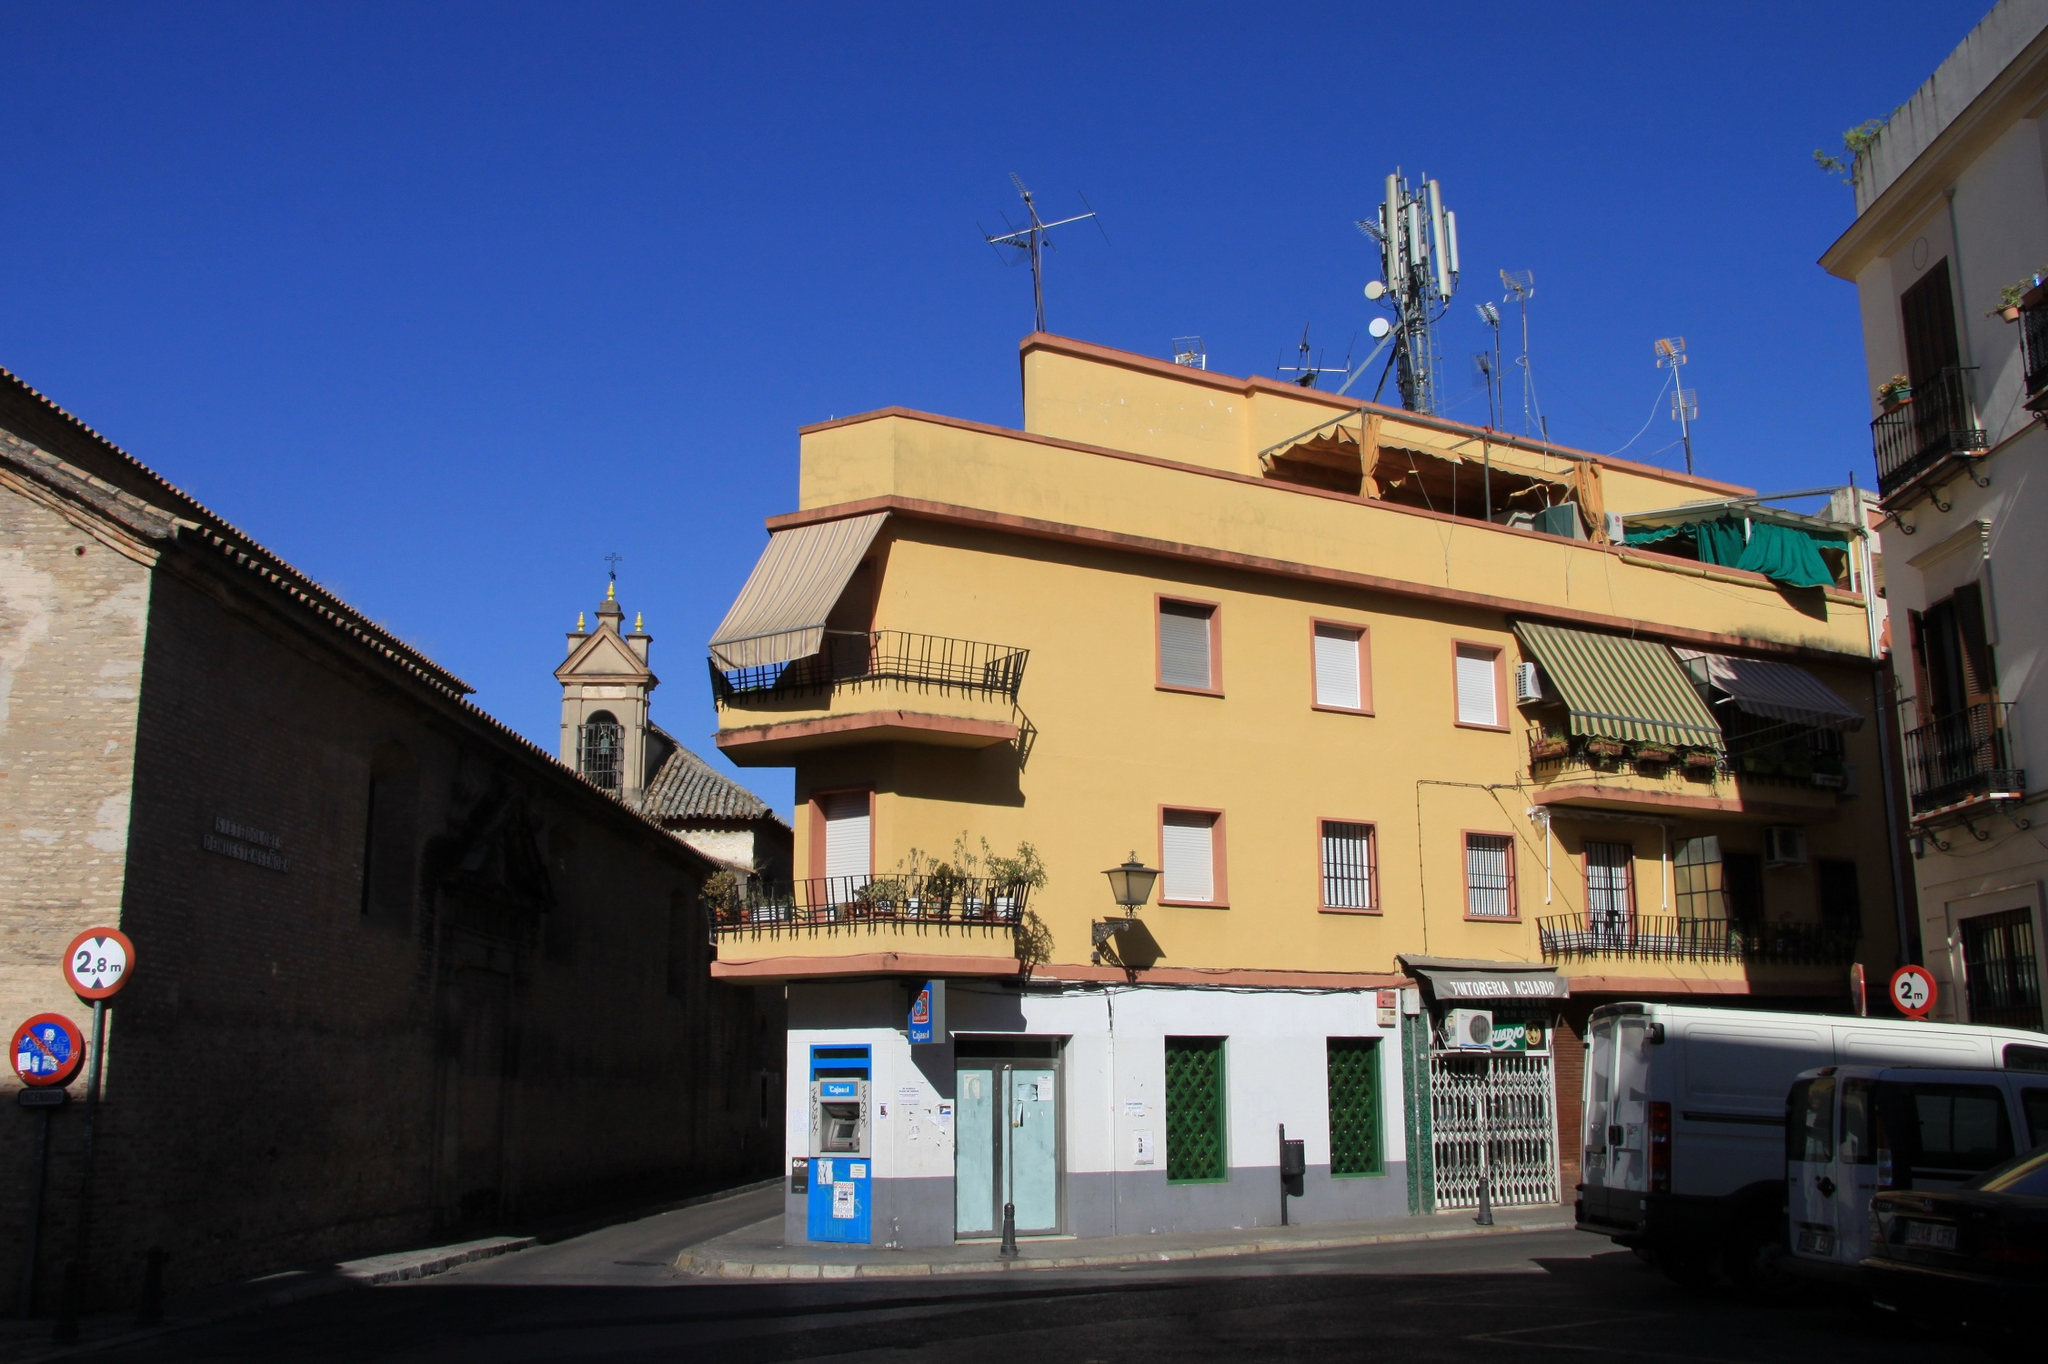Why is the building painted yellow? The yellow color of the building likely serves several purposes. Bright colors like yellow are often used in urban environments to create a cheerful and inviting atmosphere. Additionally, yellow can symbolize warmth and hospitality, making the building more approachable and friendly. It also contrasts well with the clear blue sky, making the structure stand out in the urban landscape. This particular shade might also be part of the local architectural tradition, reflecting cultural preferences and historical influences. 